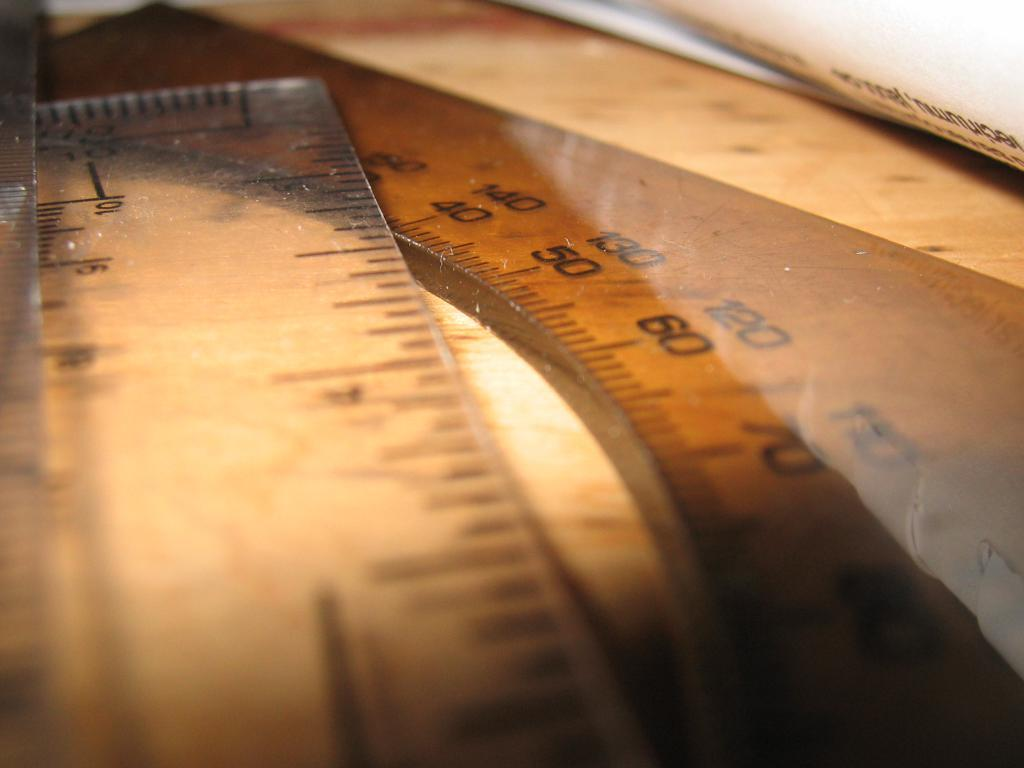Provide a one-sentence caption for the provided image. 3 inches of a plastic ruler placed over a curved ruler of about 90 centimeters. 